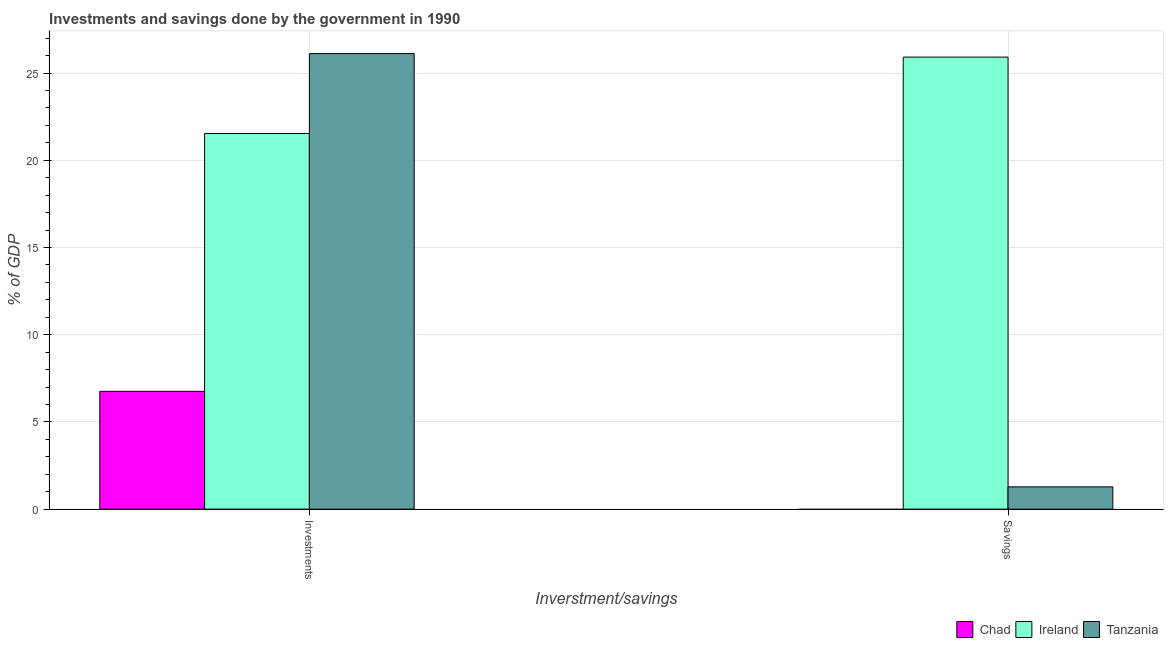How many different coloured bars are there?
Offer a terse response. 3. Are the number of bars per tick equal to the number of legend labels?
Your response must be concise. No. Are the number of bars on each tick of the X-axis equal?
Keep it short and to the point. No. How many bars are there on the 1st tick from the right?
Offer a terse response. 2. What is the label of the 1st group of bars from the left?
Your answer should be compact. Investments. What is the investments of government in Ireland?
Offer a terse response. 21.53. Across all countries, what is the maximum investments of government?
Your answer should be very brief. 26.11. Across all countries, what is the minimum savings of government?
Your response must be concise. 0. In which country was the savings of government maximum?
Your response must be concise. Ireland. What is the total investments of government in the graph?
Provide a short and direct response. 54.4. What is the difference between the investments of government in Tanzania and that in Ireland?
Your answer should be very brief. 4.58. What is the difference between the investments of government in Tanzania and the savings of government in Ireland?
Provide a succinct answer. 0.2. What is the average investments of government per country?
Offer a terse response. 18.13. What is the difference between the savings of government and investments of government in Ireland?
Offer a very short reply. 4.38. In how many countries, is the investments of government greater than 3 %?
Give a very brief answer. 3. What is the ratio of the investments of government in Chad to that in Ireland?
Make the answer very short. 0.31. Is the savings of government in Ireland less than that in Tanzania?
Your answer should be very brief. No. How many bars are there?
Give a very brief answer. 5. Are all the bars in the graph horizontal?
Keep it short and to the point. No. What is the difference between two consecutive major ticks on the Y-axis?
Your answer should be compact. 5. Are the values on the major ticks of Y-axis written in scientific E-notation?
Give a very brief answer. No. Does the graph contain any zero values?
Your response must be concise. Yes. Does the graph contain grids?
Give a very brief answer. Yes. Where does the legend appear in the graph?
Your response must be concise. Bottom right. What is the title of the graph?
Keep it short and to the point. Investments and savings done by the government in 1990. What is the label or title of the X-axis?
Keep it short and to the point. Inverstment/savings. What is the label or title of the Y-axis?
Your answer should be compact. % of GDP. What is the % of GDP in Chad in Investments?
Offer a terse response. 6.75. What is the % of GDP in Ireland in Investments?
Provide a short and direct response. 21.53. What is the % of GDP in Tanzania in Investments?
Your answer should be very brief. 26.11. What is the % of GDP in Chad in Savings?
Your answer should be very brief. 0. What is the % of GDP of Ireland in Savings?
Make the answer very short. 25.91. What is the % of GDP of Tanzania in Savings?
Ensure brevity in your answer.  1.28. Across all Inverstment/savings, what is the maximum % of GDP of Chad?
Your answer should be compact. 6.75. Across all Inverstment/savings, what is the maximum % of GDP in Ireland?
Provide a succinct answer. 25.91. Across all Inverstment/savings, what is the maximum % of GDP of Tanzania?
Make the answer very short. 26.11. Across all Inverstment/savings, what is the minimum % of GDP of Chad?
Your response must be concise. 0. Across all Inverstment/savings, what is the minimum % of GDP of Ireland?
Offer a terse response. 21.53. Across all Inverstment/savings, what is the minimum % of GDP in Tanzania?
Make the answer very short. 1.28. What is the total % of GDP in Chad in the graph?
Make the answer very short. 6.75. What is the total % of GDP of Ireland in the graph?
Provide a short and direct response. 47.45. What is the total % of GDP of Tanzania in the graph?
Ensure brevity in your answer.  27.39. What is the difference between the % of GDP of Ireland in Investments and that in Savings?
Make the answer very short. -4.38. What is the difference between the % of GDP in Tanzania in Investments and that in Savings?
Keep it short and to the point. 24.83. What is the difference between the % of GDP of Chad in Investments and the % of GDP of Ireland in Savings?
Offer a very short reply. -19.16. What is the difference between the % of GDP of Chad in Investments and the % of GDP of Tanzania in Savings?
Give a very brief answer. 5.48. What is the difference between the % of GDP in Ireland in Investments and the % of GDP in Tanzania in Savings?
Offer a very short reply. 20.25. What is the average % of GDP of Chad per Inverstment/savings?
Your answer should be compact. 3.38. What is the average % of GDP in Ireland per Inverstment/savings?
Offer a very short reply. 23.72. What is the average % of GDP in Tanzania per Inverstment/savings?
Provide a short and direct response. 13.7. What is the difference between the % of GDP in Chad and % of GDP in Ireland in Investments?
Offer a terse response. -14.78. What is the difference between the % of GDP in Chad and % of GDP in Tanzania in Investments?
Keep it short and to the point. -19.36. What is the difference between the % of GDP in Ireland and % of GDP in Tanzania in Investments?
Offer a very short reply. -4.58. What is the difference between the % of GDP in Ireland and % of GDP in Tanzania in Savings?
Your answer should be very brief. 24.63. What is the ratio of the % of GDP of Ireland in Investments to that in Savings?
Provide a short and direct response. 0.83. What is the ratio of the % of GDP of Tanzania in Investments to that in Savings?
Give a very brief answer. 20.42. What is the difference between the highest and the second highest % of GDP of Ireland?
Provide a succinct answer. 4.38. What is the difference between the highest and the second highest % of GDP of Tanzania?
Give a very brief answer. 24.83. What is the difference between the highest and the lowest % of GDP of Chad?
Keep it short and to the point. 6.75. What is the difference between the highest and the lowest % of GDP in Ireland?
Offer a terse response. 4.38. What is the difference between the highest and the lowest % of GDP in Tanzania?
Your answer should be compact. 24.83. 